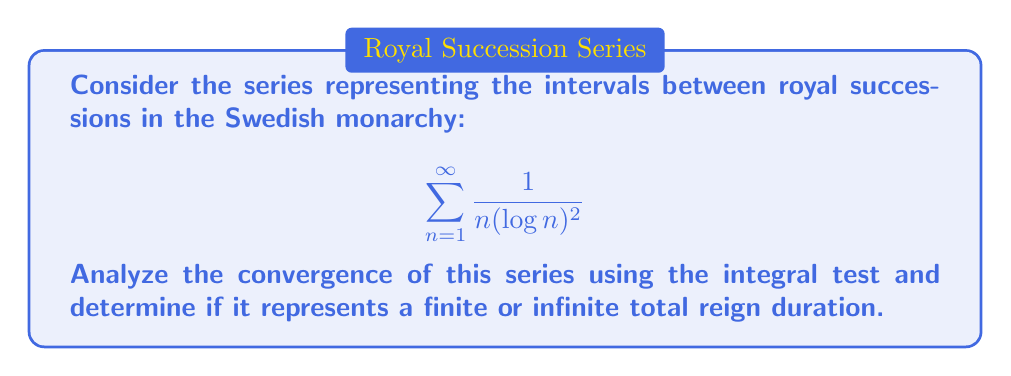Can you solve this math problem? Let's approach this step-by-step using the integral test:

1) First, let's define $f(x) = \frac{1}{x(\log x)^2}$ for $x \geq 2$. This function is positive and decreasing on $[2,\infty)$.

2) According to the integral test, the series converges if and only if the improper integral $\int_2^{\infty} f(x) dx$ converges.

3) Let's evaluate this integral:

   $$\int_2^{\infty} \frac{1}{x(\log x)^2} dx$$

4) Use the substitution $u = \log x$, so $du = \frac{1}{x} dx$:

   $$\int_{\log 2}^{\infty} \frac{1}{u^2} du$$

5) Evaluate this integral:

   $$\left[-\frac{1}{u}\right]_{\log 2}^{\infty} = 0 - \left(-\frac{1}{\log 2}\right) = \frac{1}{\log 2}$$

6) Since this improper integral converges to a finite value, by the integral test, the original series also converges.

7) The convergence of this series implies that the sum of all reign intervals is finite, suggesting a finite total reign duration when modeled by this series.
Answer: The series converges. 